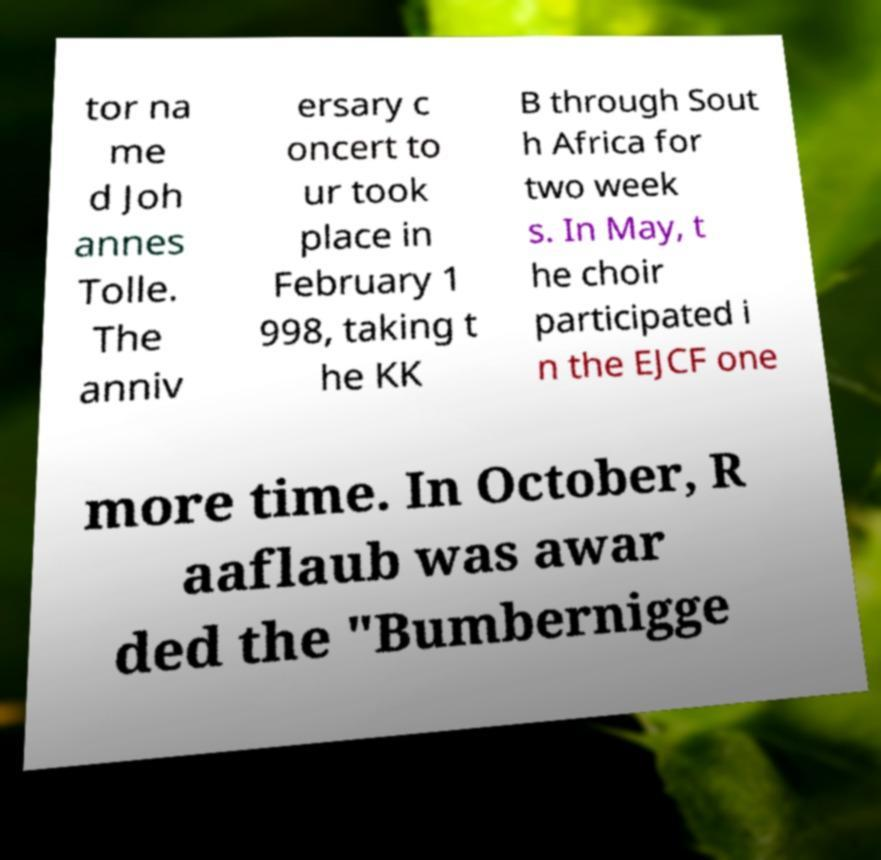I need the written content from this picture converted into text. Can you do that? tor na me d Joh annes Tolle. The anniv ersary c oncert to ur took place in February 1 998, taking t he KK B through Sout h Africa for two week s. In May, t he choir participated i n the EJCF one more time. In October, R aaflaub was awar ded the "Bumbernigge 